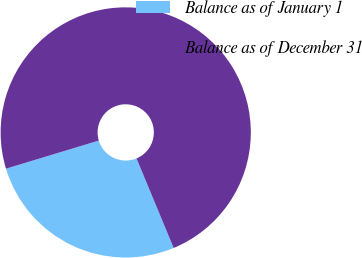Convert chart to OTSL. <chart><loc_0><loc_0><loc_500><loc_500><pie_chart><fcel>Balance as of January 1<fcel>Balance as of December 31<nl><fcel>26.58%<fcel>73.42%<nl></chart> 